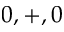<formula> <loc_0><loc_0><loc_500><loc_500>0 , + , 0</formula> 